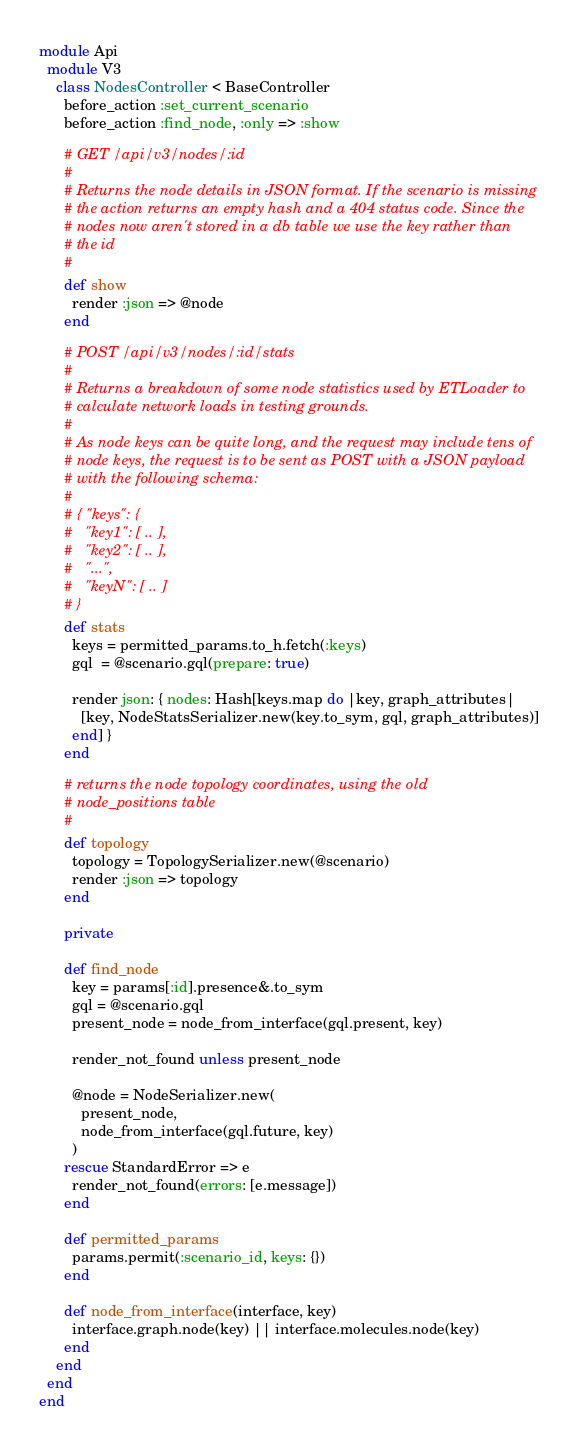Convert code to text. <code><loc_0><loc_0><loc_500><loc_500><_Ruby_>module Api
  module V3
    class NodesController < BaseController
      before_action :set_current_scenario
      before_action :find_node, :only => :show

      # GET /api/v3/nodes/:id
      #
      # Returns the node details in JSON format. If the scenario is missing
      # the action returns an empty hash and a 404 status code. Since the
      # nodes now aren't stored in a db table we use the key rather than
      # the id
      #
      def show
        render :json => @node
      end

      # POST /api/v3/nodes/:id/stats
      #
      # Returns a breakdown of some node statistics used by ETLoader to
      # calculate network loads in testing grounds.
      #
      # As node keys can be quite long, and the request may include tens of
      # node keys, the request is to be sent as POST with a JSON payload
      # with the following schema:
      #
      # { "keys": {
      #   "key1": [ .. ],
      #   "key2": [ .. ],
      #   "...",
      #   "keyN": [ .. ]
      # }
      def stats
        keys = permitted_params.to_h.fetch(:keys)
        gql  = @scenario.gql(prepare: true)

        render json: { nodes: Hash[keys.map do |key, graph_attributes|
          [key, NodeStatsSerializer.new(key.to_sym, gql, graph_attributes)]
        end] }
      end

      # returns the node topology coordinates, using the old
      # node_positions table
      #
      def topology
        topology = TopologySerializer.new(@scenario)
        render :json => topology
      end

      private

      def find_node
        key = params[:id].presence&.to_sym
        gql = @scenario.gql
        present_node = node_from_interface(gql.present, key)

        render_not_found unless present_node

        @node = NodeSerializer.new(
          present_node,
          node_from_interface(gql.future, key)
        )
      rescue StandardError => e
        render_not_found(errors: [e.message])
      end

      def permitted_params
        params.permit(:scenario_id, keys: {})
      end

      def node_from_interface(interface, key)
        interface.graph.node(key) || interface.molecules.node(key)
      end
    end
  end
end
</code> 